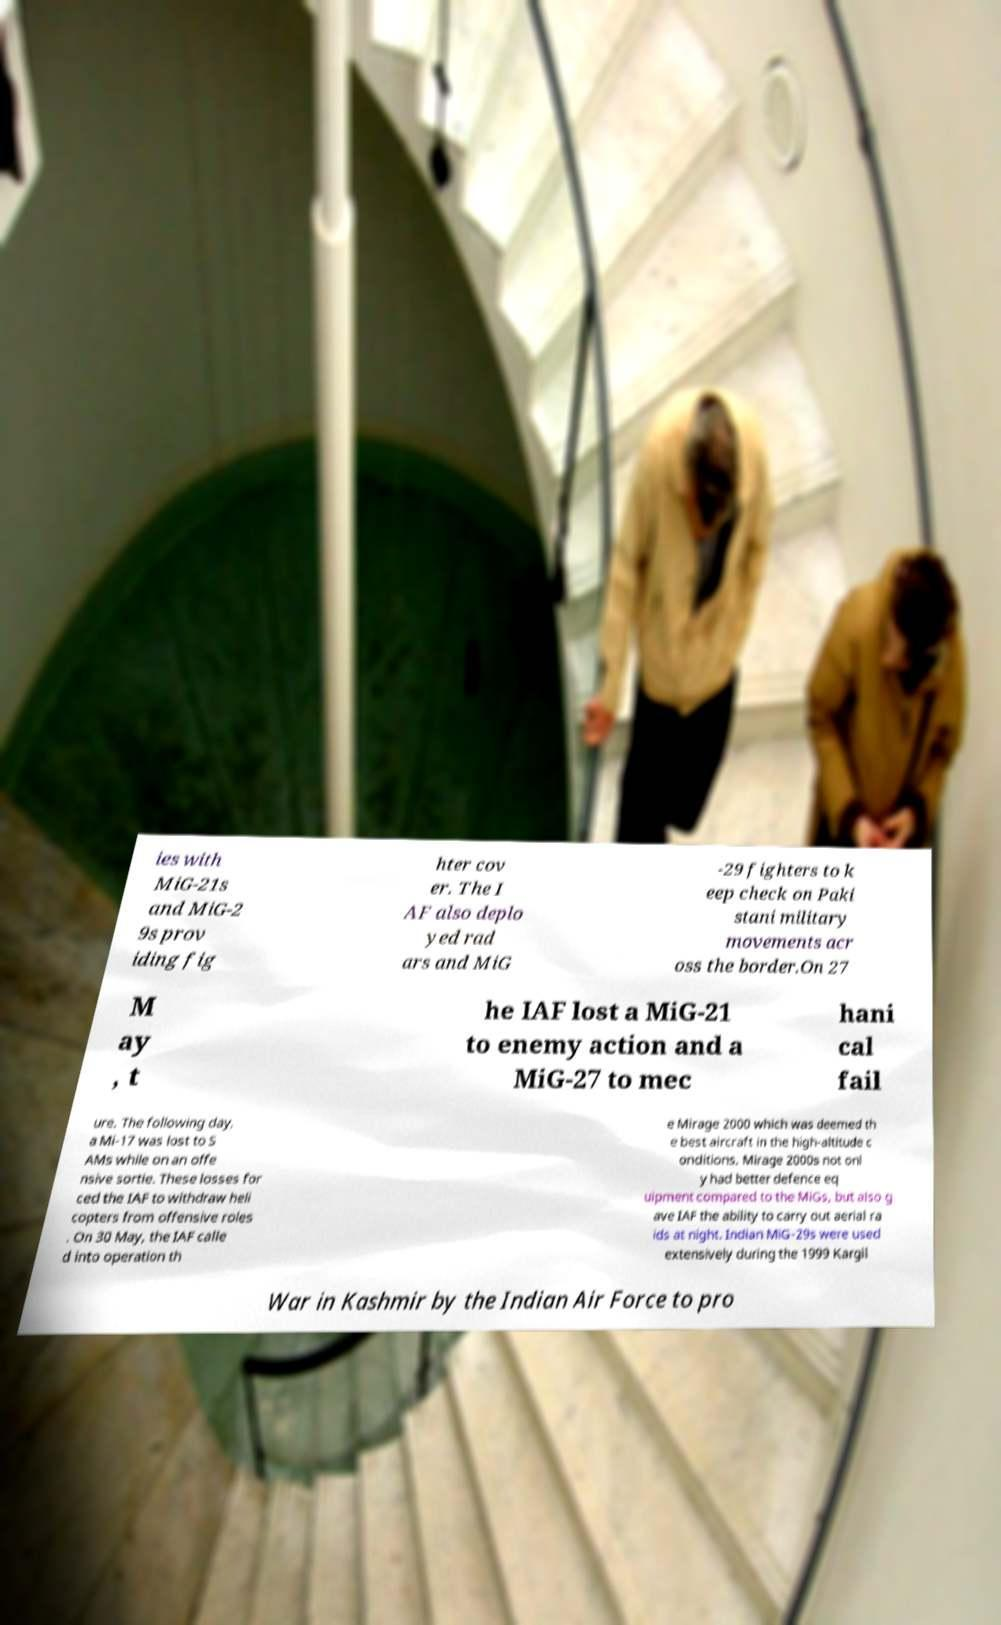There's text embedded in this image that I need extracted. Can you transcribe it verbatim? ies with MiG-21s and MiG-2 9s prov iding fig hter cov er. The I AF also deplo yed rad ars and MiG -29 fighters to k eep check on Paki stani military movements acr oss the border.On 27 M ay , t he IAF lost a MiG-21 to enemy action and a MiG-27 to mec hani cal fail ure. The following day, a Mi-17 was lost to S AMs while on an offe nsive sortie. These losses for ced the IAF to withdraw heli copters from offensive roles . On 30 May, the IAF calle d into operation th e Mirage 2000 which was deemed th e best aircraft in the high-altitude c onditions. Mirage 2000s not onl y had better defence eq uipment compared to the MiGs, but also g ave IAF the ability to carry out aerial ra ids at night. Indian MiG-29s were used extensively during the 1999 Kargil War in Kashmir by the Indian Air Force to pro 